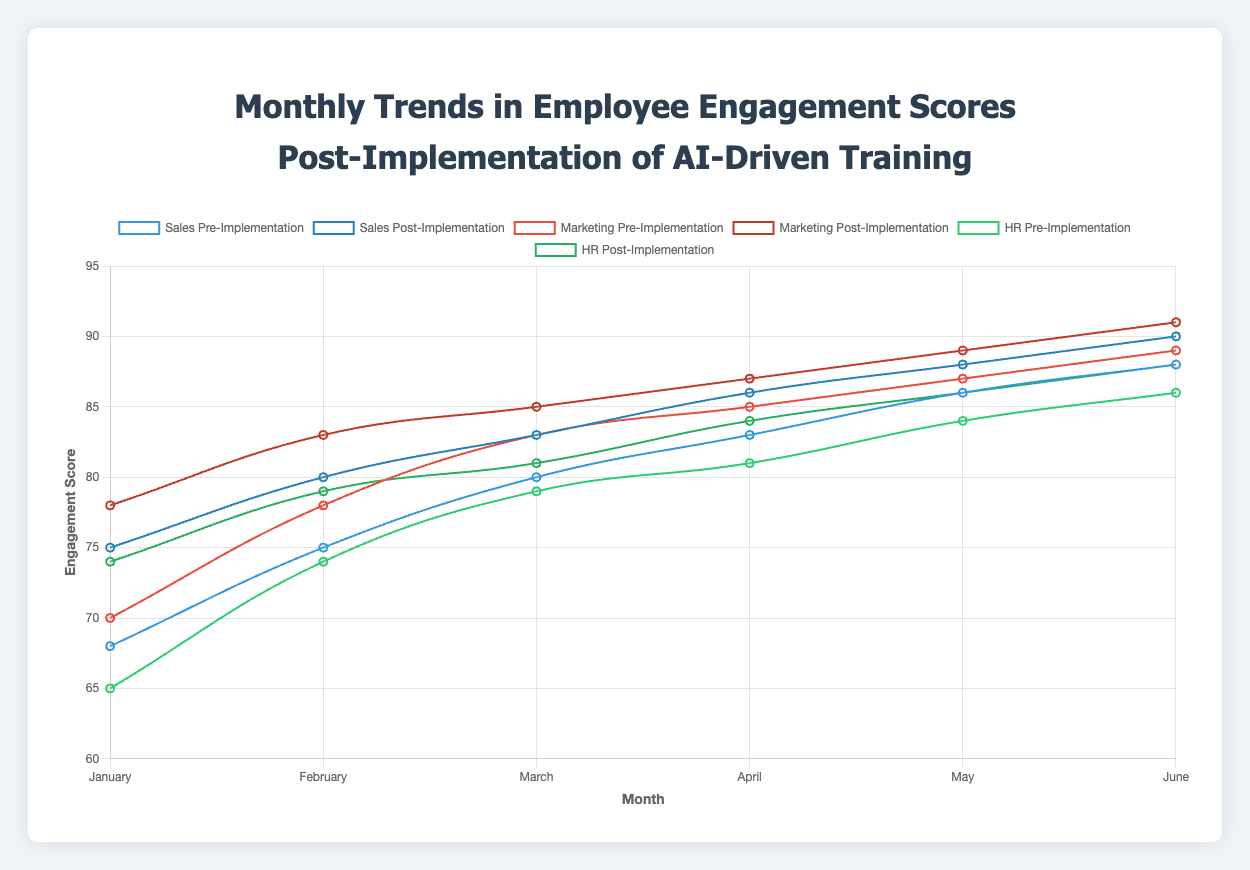What is the overall change in the engagement score for the Sales department from January to June? To find the overall change, subtract the January post-implementation score from the June post-implementation score. Sales department in January: 75, Sales department in June: 90. So, 90 - 75 = 15.
Answer: 15 Which department showed the highest increase in engagement score from pre-implementation to post-implementation in January? Compare the differences between pre-implementation and post-implementation scores for each department in January. Sales: 75 - 68 = 7, Marketing: 78 - 70 = 8, HR: 74 - 65 = 9. HR has the highest increase.
Answer: HR Between February and March, which department had the most significant absolute increase in post-implementation engagement scores? Calculate the differences in post-implementation scores from February to March for each department. Sales: 83 - 80 = 3, Marketing: 85 - 83 = 2, HR: 81 - 79 = 2. Sales had the most significant increase.
Answer: Sales What is the average post-implementation engagement score for the Marketing department from January to June? Add the post-implementation scores for Marketing from January to June and divide by the number of months (6). (78 + 83 + 85 + 87 + 89 + 91) / 6 = 513 / 6 = 85.5.
Answer: 85.5 In which month does the HR department achieve an engagement score of 88, and is it before or after implementation? According to the data provided, in June, the HR department's post-implementation engagement score reaches 88.
Answer: June, post-implementation What is the difference in the engagement score growth pre- and post-implementation across all departments from January to February? Calculate the growth for each month (February - January) and then the difference between post- and pre-implementation. Sales: Pre (75-68) = 7, Post (80-75) = 5. Marketing: Pre (78-70) = 8, Post (83-78) = 5. HR: Pre (74-65) = 9, Post (79-74) = 5. Total pre-implementation growth = 7+8+9 = 24, total post-implementation growth = 5+5+5 = 15. Difference = 24 - 15 = 9.
Answer: 9 Which department had the highest engagement score in April post-implementation? Compare the post-implementation scores for all departments in April. Sales: 86, Marketing: 87, HR: 84. Marketing has the highest score of 87.
Answer: Marketing Which department showed the least improvement in engagement score from pre- to post-implementation in May? Compare the differences between pre- and post-implementation scores for each department in May. Sales: 88 - 86 = 2, Marketing: 89 - 87 = 2, HR: 86 - 84 = 2. All departments have the same improvement of 2 points.
Answer: Sales, Marketing, HR By how many points did the post-implementation engagement score for the Marketing department increase from January to June? Subtract the post-implementation score in January from that in June. June: 91, January: 78. So, 91 - 78 = 13.
Answer: 13 